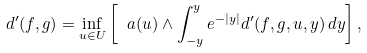<formula> <loc_0><loc_0><loc_500><loc_500>d ^ { \prime } ( f , g ) = \inf _ { u \in U } \left [ \ a ( u ) \wedge \int _ { - y } ^ { y } e ^ { - | y | } d ^ { \prime } ( f , g , u , y ) \, d y \right ] ,</formula> 